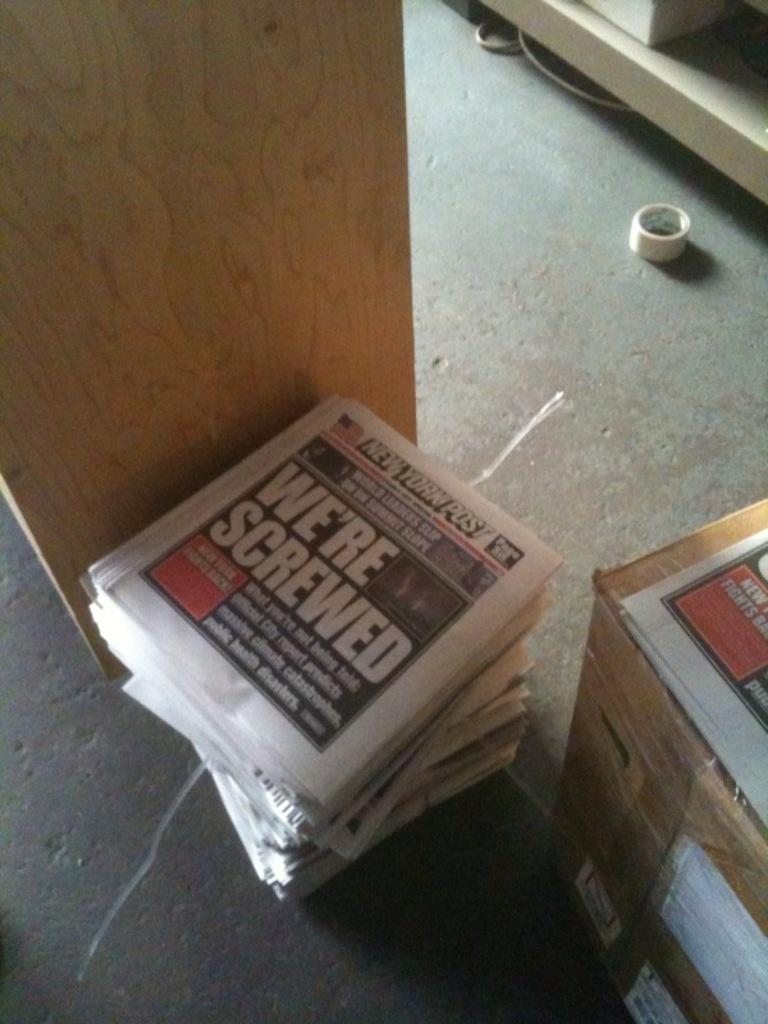<image>
Provide a brief description of the given image. a stack of newspapers with one of them titled 'we're screwed' in bold white lettering 